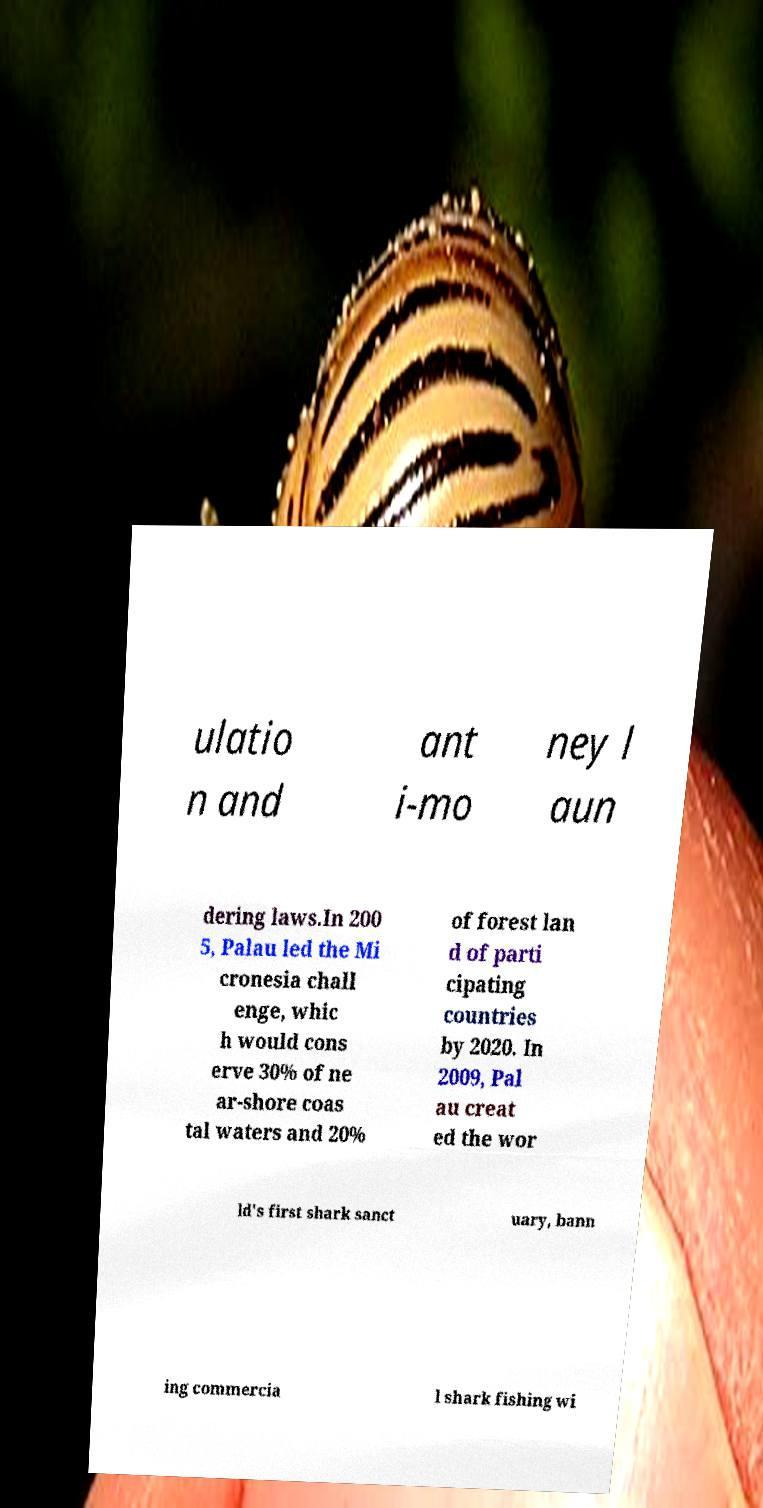Please read and relay the text visible in this image. What does it say? ulatio n and ant i-mo ney l aun dering laws.In 200 5, Palau led the Mi cronesia chall enge, whic h would cons erve 30% of ne ar-shore coas tal waters and 20% of forest lan d of parti cipating countries by 2020. In 2009, Pal au creat ed the wor ld's first shark sanct uary, bann ing commercia l shark fishing wi 